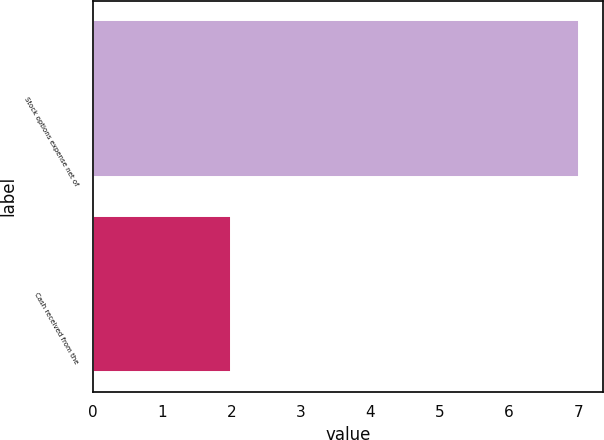<chart> <loc_0><loc_0><loc_500><loc_500><bar_chart><fcel>Stock options expense net of<fcel>Cash received from the<nl><fcel>7<fcel>2<nl></chart> 